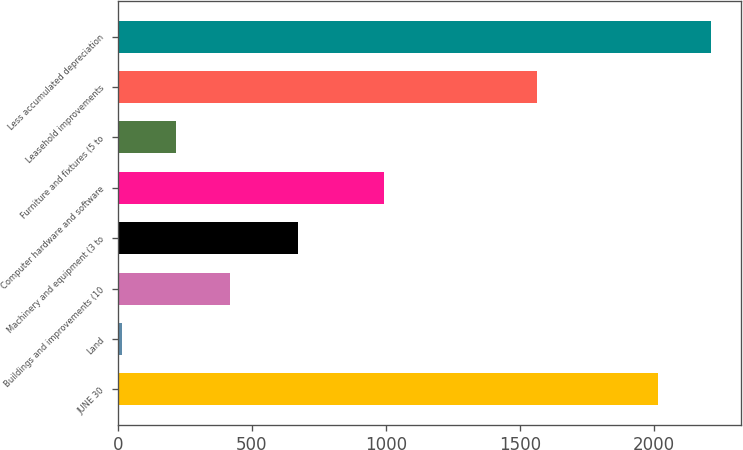<chart> <loc_0><loc_0><loc_500><loc_500><bar_chart><fcel>JUNE 30<fcel>Land<fcel>Buildings and improvements (10<fcel>Machinery and equipment (3 to<fcel>Computer hardware and software<fcel>Furniture and fixtures (5 to<fcel>Leasehold improvements<fcel>Less accumulated depreciation<nl><fcel>2014<fcel>15.4<fcel>417.78<fcel>673.9<fcel>994.8<fcel>216.59<fcel>1565.7<fcel>2215.19<nl></chart> 